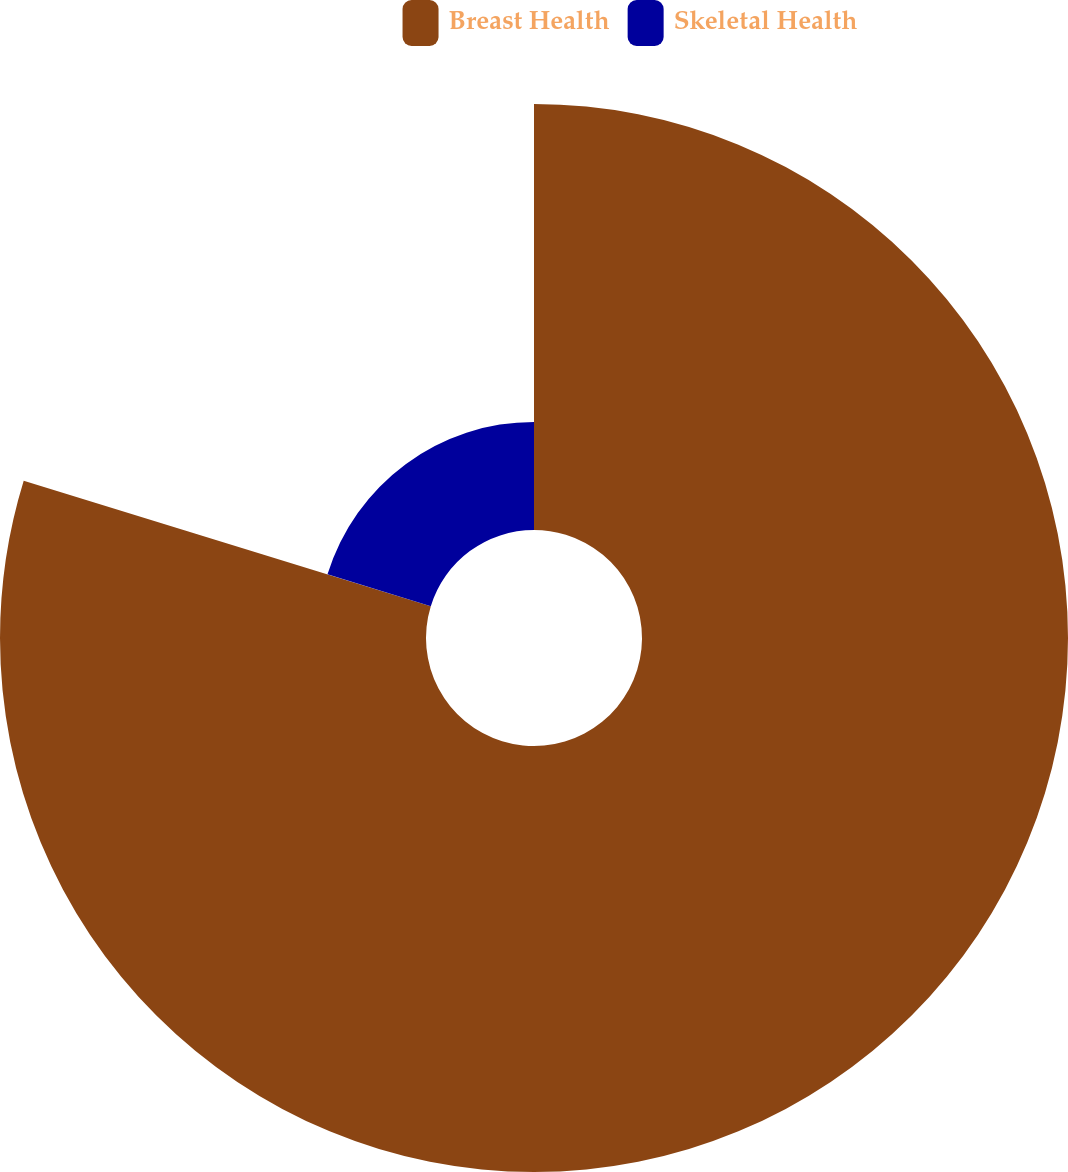<chart> <loc_0><loc_0><loc_500><loc_500><pie_chart><fcel>Breast Health<fcel>Skeletal Health<nl><fcel>79.76%<fcel>20.24%<nl></chart> 